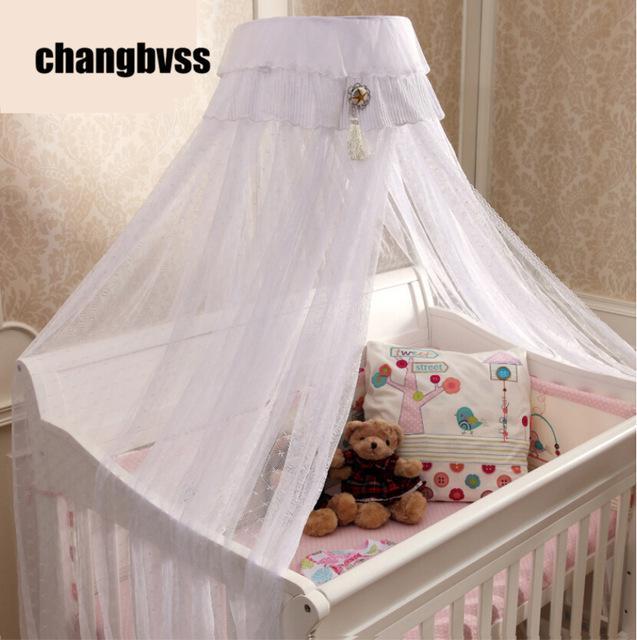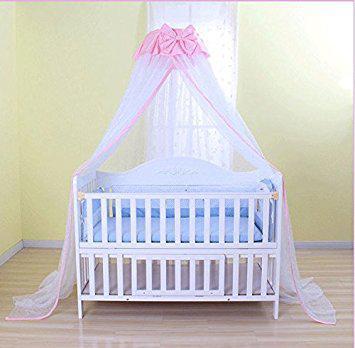The first image is the image on the left, the second image is the image on the right. Evaluate the accuracy of this statement regarding the images: "There are two pink canopies .". Is it true? Answer yes or no. No. The first image is the image on the left, the second image is the image on the right. For the images displayed, is the sentence "There is exactly one baby crib." factually correct? Answer yes or no. No. 